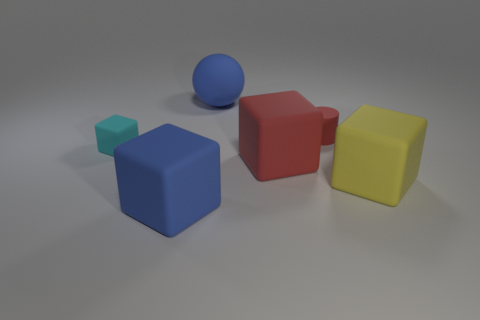Subtract 1 blocks. How many blocks are left? 3 Add 4 big rubber cubes. How many objects exist? 10 Subtract all balls. How many objects are left? 5 Subtract 1 red cubes. How many objects are left? 5 Subtract all tiny blue matte cylinders. Subtract all cylinders. How many objects are left? 5 Add 4 big blue blocks. How many big blue blocks are left? 5 Add 3 green spheres. How many green spheres exist? 3 